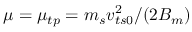Convert formula to latex. <formula><loc_0><loc_0><loc_500><loc_500>\mu = \mu _ { t p } = m _ { s } v _ { t s 0 } ^ { 2 } / ( 2 { B _ { m } } )</formula> 